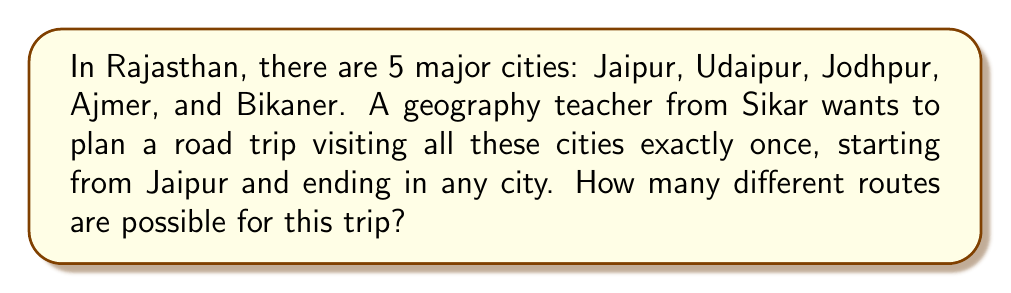Solve this math problem. Let's approach this step-by-step:

1) We start with Jaipur as the fixed starting point. This leaves us with 4 cities to arrange in a sequence.

2) This is a permutation problem, as the order of cities matters in the route.

3) The number of permutations of n distinct objects is given by n!

4) In this case, we have 4 cities to arrange (excluding Jaipur), so we need to calculate 4!

5) Let's calculate 4!:
   $$4! = 4 \times 3 \times 2 \times 1 = 24$$

6) Therefore, there are 24 different possible routes.

To visualize this, we can think of it as:
- We have 4 choices for the second city
- Then 3 choices for the third city
- Then 2 choices for the fourth city
- And finally, 1 choice for the last city

This gives us: $4 \times 3 \times 2 \times 1 = 24$

This method of counting is precisely what factorial represents.
Answer: 24 different routes 